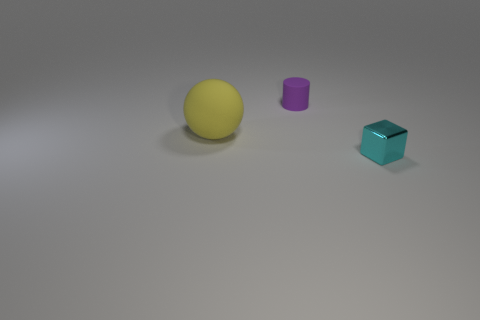Is the material of the ball the same as the tiny object that is in front of the small purple thing?
Your answer should be compact. No. What number of objects are tiny things in front of the large matte sphere or tiny yellow objects?
Make the answer very short. 1. Does the small metallic object have the same shape as the small object behind the cyan metallic block?
Keep it short and to the point. No. How many tiny objects are both in front of the rubber sphere and left of the cyan shiny block?
Your answer should be compact. 0. What size is the cyan block in front of the object that is behind the yellow matte ball?
Your answer should be compact. Small. Are there any purple matte cubes?
Offer a terse response. No. What is the material of the thing that is both on the right side of the big yellow object and in front of the purple cylinder?
Give a very brief answer. Metal. Is the number of tiny cyan shiny things to the left of the small purple object greater than the number of cyan blocks in front of the yellow object?
Ensure brevity in your answer.  No. Are there any purple rubber cylinders of the same size as the metal thing?
Ensure brevity in your answer.  Yes. What size is the cyan shiny block right of the object that is to the left of the small object behind the cyan thing?
Offer a terse response. Small. 